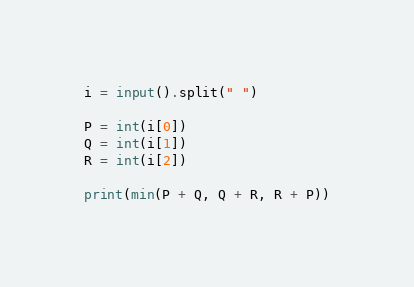<code> <loc_0><loc_0><loc_500><loc_500><_Python_>i = input().split(" ")

P = int(i[0])
Q = int(i[1])
R = int(i[2])

print(min(P + Q, Q + R, R + P))
</code> 